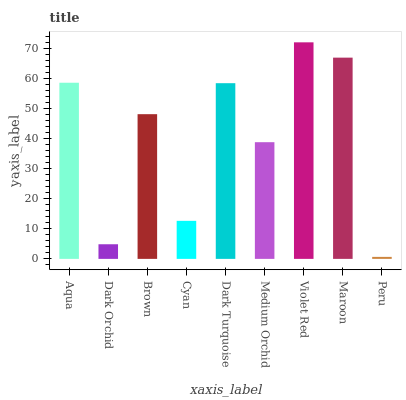Is Peru the minimum?
Answer yes or no. Yes. Is Violet Red the maximum?
Answer yes or no. Yes. Is Dark Orchid the minimum?
Answer yes or no. No. Is Dark Orchid the maximum?
Answer yes or no. No. Is Aqua greater than Dark Orchid?
Answer yes or no. Yes. Is Dark Orchid less than Aqua?
Answer yes or no. Yes. Is Dark Orchid greater than Aqua?
Answer yes or no. No. Is Aqua less than Dark Orchid?
Answer yes or no. No. Is Brown the high median?
Answer yes or no. Yes. Is Brown the low median?
Answer yes or no. Yes. Is Violet Red the high median?
Answer yes or no. No. Is Cyan the low median?
Answer yes or no. No. 